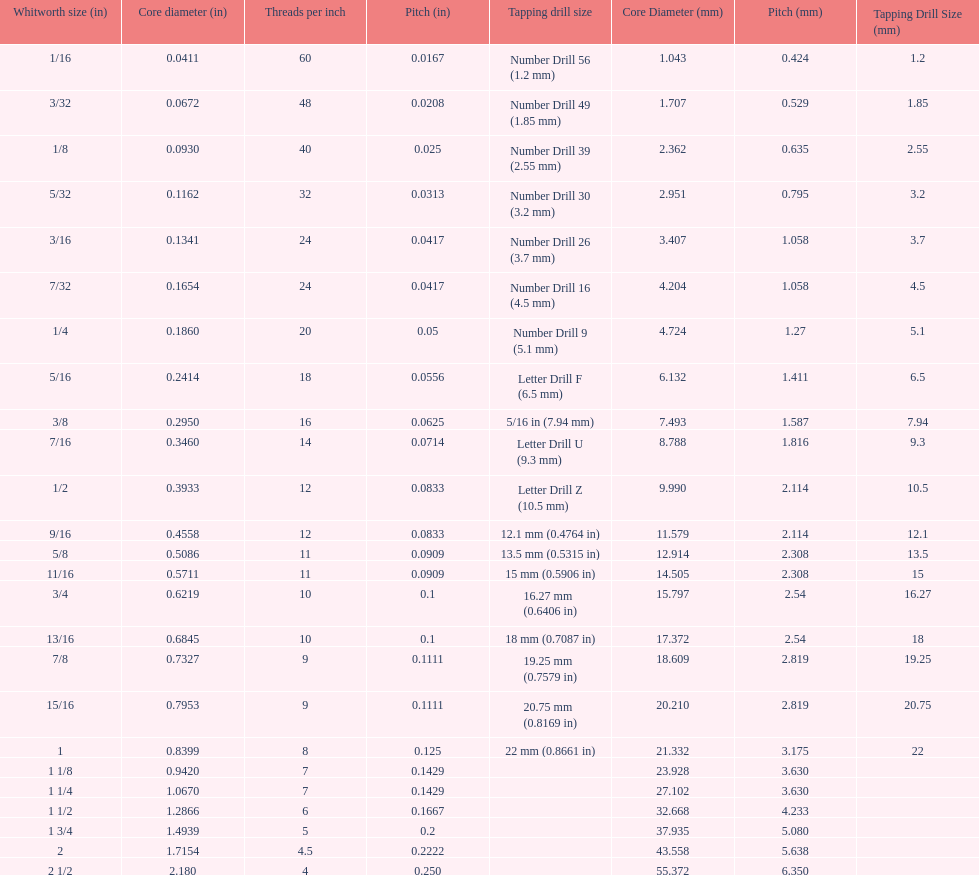What is the next whitworth size (in) below 1/8? 5/32. 